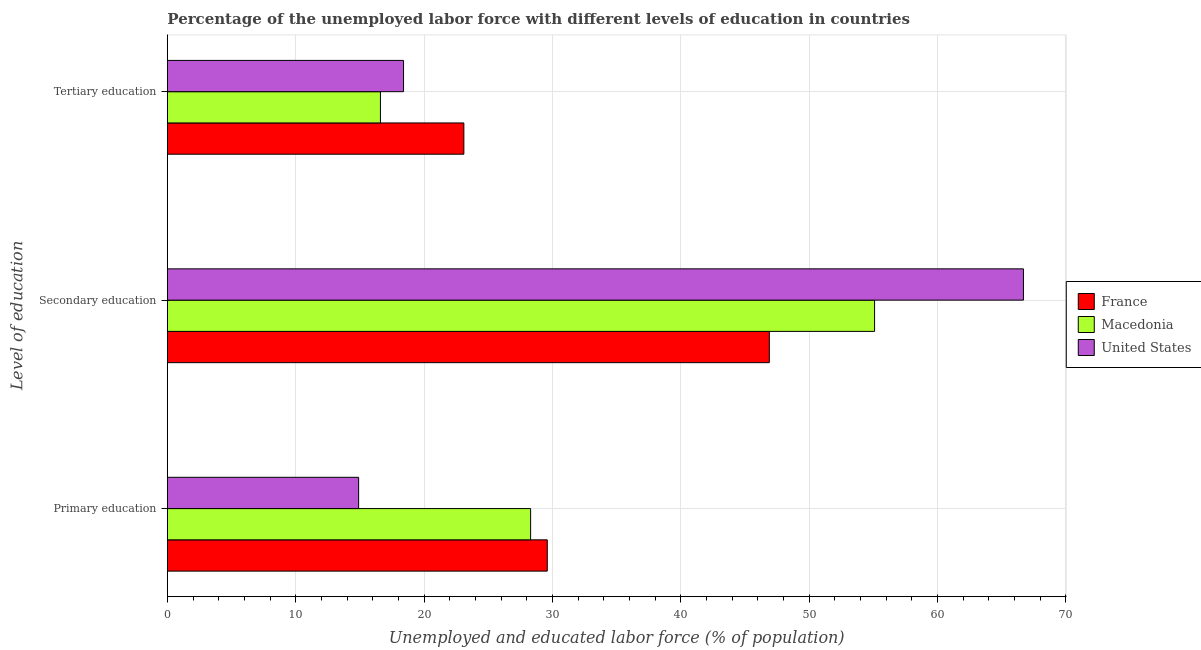How many different coloured bars are there?
Keep it short and to the point. 3. How many groups of bars are there?
Keep it short and to the point. 3. How many bars are there on the 2nd tick from the top?
Your answer should be compact. 3. How many bars are there on the 3rd tick from the bottom?
Make the answer very short. 3. What is the label of the 3rd group of bars from the top?
Give a very brief answer. Primary education. What is the percentage of labor force who received secondary education in United States?
Provide a succinct answer. 66.7. Across all countries, what is the maximum percentage of labor force who received tertiary education?
Make the answer very short. 23.1. Across all countries, what is the minimum percentage of labor force who received secondary education?
Offer a terse response. 46.9. In which country was the percentage of labor force who received tertiary education minimum?
Keep it short and to the point. Macedonia. What is the total percentage of labor force who received primary education in the graph?
Ensure brevity in your answer.  72.8. What is the difference between the percentage of labor force who received tertiary education in France and that in United States?
Ensure brevity in your answer.  4.7. What is the difference between the percentage of labor force who received primary education in France and the percentage of labor force who received secondary education in Macedonia?
Make the answer very short. -25.5. What is the average percentage of labor force who received secondary education per country?
Offer a terse response. 56.23. What is the difference between the percentage of labor force who received secondary education and percentage of labor force who received tertiary education in France?
Offer a terse response. 23.8. What is the ratio of the percentage of labor force who received primary education in France to that in United States?
Give a very brief answer. 1.99. Is the percentage of labor force who received secondary education in United States less than that in Macedonia?
Offer a terse response. No. What is the difference between the highest and the second highest percentage of labor force who received tertiary education?
Keep it short and to the point. 4.7. What is the difference between the highest and the lowest percentage of labor force who received primary education?
Provide a short and direct response. 14.7. In how many countries, is the percentage of labor force who received primary education greater than the average percentage of labor force who received primary education taken over all countries?
Offer a terse response. 2. What does the 2nd bar from the top in Secondary education represents?
Offer a very short reply. Macedonia. What does the 3rd bar from the bottom in Primary education represents?
Keep it short and to the point. United States. How many countries are there in the graph?
Offer a terse response. 3. Does the graph contain grids?
Make the answer very short. Yes. Where does the legend appear in the graph?
Keep it short and to the point. Center right. How are the legend labels stacked?
Your answer should be compact. Vertical. What is the title of the graph?
Your response must be concise. Percentage of the unemployed labor force with different levels of education in countries. What is the label or title of the X-axis?
Your answer should be compact. Unemployed and educated labor force (% of population). What is the label or title of the Y-axis?
Your answer should be compact. Level of education. What is the Unemployed and educated labor force (% of population) of France in Primary education?
Make the answer very short. 29.6. What is the Unemployed and educated labor force (% of population) of Macedonia in Primary education?
Ensure brevity in your answer.  28.3. What is the Unemployed and educated labor force (% of population) of United States in Primary education?
Ensure brevity in your answer.  14.9. What is the Unemployed and educated labor force (% of population) in France in Secondary education?
Offer a very short reply. 46.9. What is the Unemployed and educated labor force (% of population) of Macedonia in Secondary education?
Your response must be concise. 55.1. What is the Unemployed and educated labor force (% of population) of United States in Secondary education?
Your answer should be very brief. 66.7. What is the Unemployed and educated labor force (% of population) in France in Tertiary education?
Offer a very short reply. 23.1. What is the Unemployed and educated labor force (% of population) in Macedonia in Tertiary education?
Your answer should be compact. 16.6. What is the Unemployed and educated labor force (% of population) of United States in Tertiary education?
Provide a succinct answer. 18.4. Across all Level of education, what is the maximum Unemployed and educated labor force (% of population) of France?
Your answer should be very brief. 46.9. Across all Level of education, what is the maximum Unemployed and educated labor force (% of population) in Macedonia?
Ensure brevity in your answer.  55.1. Across all Level of education, what is the maximum Unemployed and educated labor force (% of population) in United States?
Keep it short and to the point. 66.7. Across all Level of education, what is the minimum Unemployed and educated labor force (% of population) in France?
Give a very brief answer. 23.1. Across all Level of education, what is the minimum Unemployed and educated labor force (% of population) of Macedonia?
Provide a short and direct response. 16.6. Across all Level of education, what is the minimum Unemployed and educated labor force (% of population) in United States?
Keep it short and to the point. 14.9. What is the total Unemployed and educated labor force (% of population) in France in the graph?
Ensure brevity in your answer.  99.6. What is the total Unemployed and educated labor force (% of population) in United States in the graph?
Provide a succinct answer. 100. What is the difference between the Unemployed and educated labor force (% of population) of France in Primary education and that in Secondary education?
Your answer should be compact. -17.3. What is the difference between the Unemployed and educated labor force (% of population) in Macedonia in Primary education and that in Secondary education?
Offer a very short reply. -26.8. What is the difference between the Unemployed and educated labor force (% of population) of United States in Primary education and that in Secondary education?
Provide a succinct answer. -51.8. What is the difference between the Unemployed and educated labor force (% of population) in France in Secondary education and that in Tertiary education?
Offer a terse response. 23.8. What is the difference between the Unemployed and educated labor force (% of population) in Macedonia in Secondary education and that in Tertiary education?
Provide a short and direct response. 38.5. What is the difference between the Unemployed and educated labor force (% of population) in United States in Secondary education and that in Tertiary education?
Provide a succinct answer. 48.3. What is the difference between the Unemployed and educated labor force (% of population) in France in Primary education and the Unemployed and educated labor force (% of population) in Macedonia in Secondary education?
Give a very brief answer. -25.5. What is the difference between the Unemployed and educated labor force (% of population) in France in Primary education and the Unemployed and educated labor force (% of population) in United States in Secondary education?
Give a very brief answer. -37.1. What is the difference between the Unemployed and educated labor force (% of population) of Macedonia in Primary education and the Unemployed and educated labor force (% of population) of United States in Secondary education?
Offer a terse response. -38.4. What is the difference between the Unemployed and educated labor force (% of population) of France in Primary education and the Unemployed and educated labor force (% of population) of Macedonia in Tertiary education?
Your answer should be very brief. 13. What is the difference between the Unemployed and educated labor force (% of population) in France in Primary education and the Unemployed and educated labor force (% of population) in United States in Tertiary education?
Give a very brief answer. 11.2. What is the difference between the Unemployed and educated labor force (% of population) of France in Secondary education and the Unemployed and educated labor force (% of population) of Macedonia in Tertiary education?
Offer a terse response. 30.3. What is the difference between the Unemployed and educated labor force (% of population) in France in Secondary education and the Unemployed and educated labor force (% of population) in United States in Tertiary education?
Offer a very short reply. 28.5. What is the difference between the Unemployed and educated labor force (% of population) in Macedonia in Secondary education and the Unemployed and educated labor force (% of population) in United States in Tertiary education?
Provide a succinct answer. 36.7. What is the average Unemployed and educated labor force (% of population) of France per Level of education?
Keep it short and to the point. 33.2. What is the average Unemployed and educated labor force (% of population) in Macedonia per Level of education?
Ensure brevity in your answer.  33.33. What is the average Unemployed and educated labor force (% of population) of United States per Level of education?
Your answer should be compact. 33.33. What is the difference between the Unemployed and educated labor force (% of population) in France and Unemployed and educated labor force (% of population) in Macedonia in Primary education?
Your answer should be compact. 1.3. What is the difference between the Unemployed and educated labor force (% of population) of France and Unemployed and educated labor force (% of population) of United States in Secondary education?
Provide a succinct answer. -19.8. What is the ratio of the Unemployed and educated labor force (% of population) of France in Primary education to that in Secondary education?
Give a very brief answer. 0.63. What is the ratio of the Unemployed and educated labor force (% of population) of Macedonia in Primary education to that in Secondary education?
Give a very brief answer. 0.51. What is the ratio of the Unemployed and educated labor force (% of population) of United States in Primary education to that in Secondary education?
Your answer should be compact. 0.22. What is the ratio of the Unemployed and educated labor force (% of population) of France in Primary education to that in Tertiary education?
Make the answer very short. 1.28. What is the ratio of the Unemployed and educated labor force (% of population) in Macedonia in Primary education to that in Tertiary education?
Offer a terse response. 1.7. What is the ratio of the Unemployed and educated labor force (% of population) of United States in Primary education to that in Tertiary education?
Offer a terse response. 0.81. What is the ratio of the Unemployed and educated labor force (% of population) in France in Secondary education to that in Tertiary education?
Ensure brevity in your answer.  2.03. What is the ratio of the Unemployed and educated labor force (% of population) of Macedonia in Secondary education to that in Tertiary education?
Offer a very short reply. 3.32. What is the ratio of the Unemployed and educated labor force (% of population) of United States in Secondary education to that in Tertiary education?
Keep it short and to the point. 3.62. What is the difference between the highest and the second highest Unemployed and educated labor force (% of population) in Macedonia?
Offer a very short reply. 26.8. What is the difference between the highest and the second highest Unemployed and educated labor force (% of population) in United States?
Keep it short and to the point. 48.3. What is the difference between the highest and the lowest Unemployed and educated labor force (% of population) in France?
Your answer should be compact. 23.8. What is the difference between the highest and the lowest Unemployed and educated labor force (% of population) in Macedonia?
Keep it short and to the point. 38.5. What is the difference between the highest and the lowest Unemployed and educated labor force (% of population) in United States?
Ensure brevity in your answer.  51.8. 